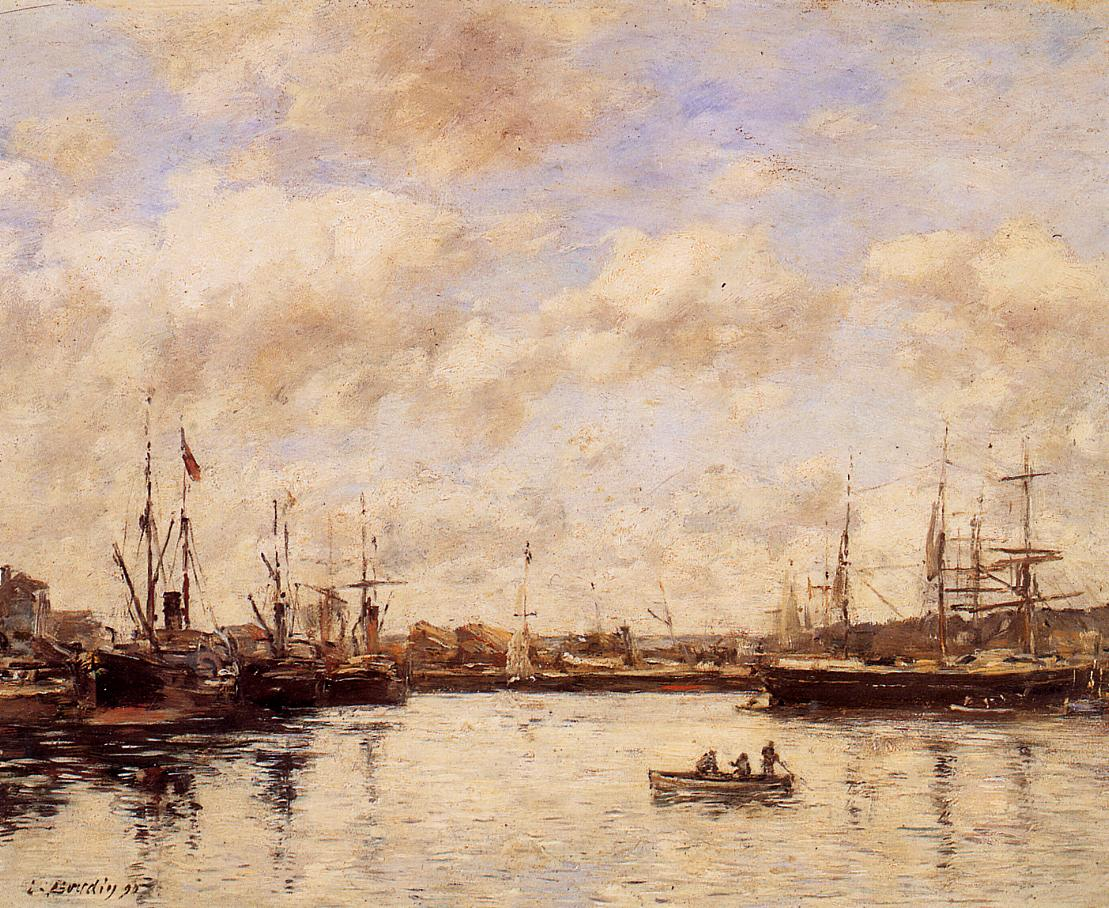Can you elaborate on the elements of the picture provided? The image showcases an impressionist painting of a peaceful harbor scene. The art style is characterized by loose and expressive brushstrokes, contributing to the overall impressionistic aesthetic. The color palette comprises mostly muted tones, creating a tranquil and serene atmosphere.

The sky is painted in a pale blue hue, dotted with soft, wispy clouds. This calm sky is beautifully reflected on the water below, which is a deeper shade of blue with gentle ripples. Several ships and boats, painted in shades of brown and black, with occasional accents of white and red, are scattered across the harbor, suggesting quiet activity.

The red and blue flags on the ships contrast against the more subdued colors with their vibrancy, drawing the viewer's eye and adding a touch of liveliness to the scene. Even though the subject matter involves numerous boats and ships, the overall mood captured is one of peace and quiet, portraying a serene moment in the bustling harbor. 